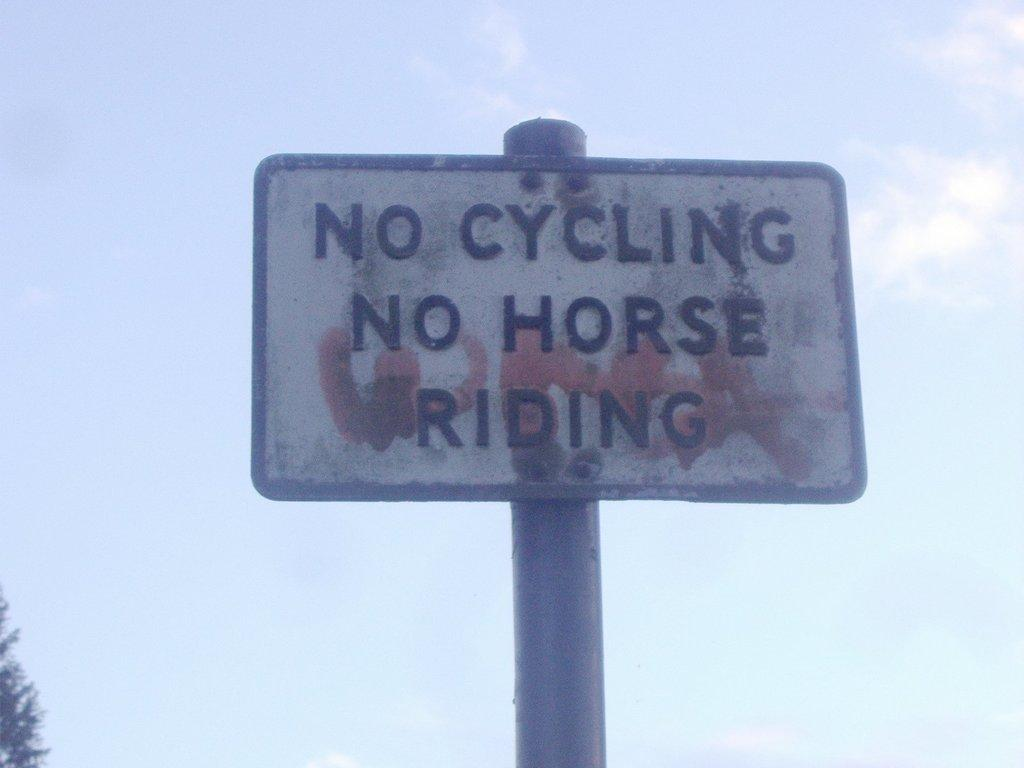<image>
Render a clear and concise summary of the photo. A sign displays that one may not ride a bicycle or a horse in this area. 